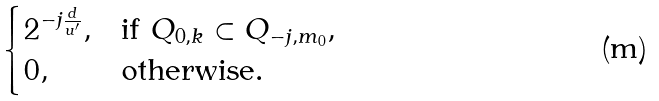Convert formula to latex. <formula><loc_0><loc_0><loc_500><loc_500>\begin{cases} 2 ^ { - j \frac { d } { u ^ { \prime } } } , & \text {if} \ Q _ { 0 , k } \subset Q _ { - j , m _ { 0 } } , \\ 0 , & \text {otherwise} . \end{cases}</formula> 